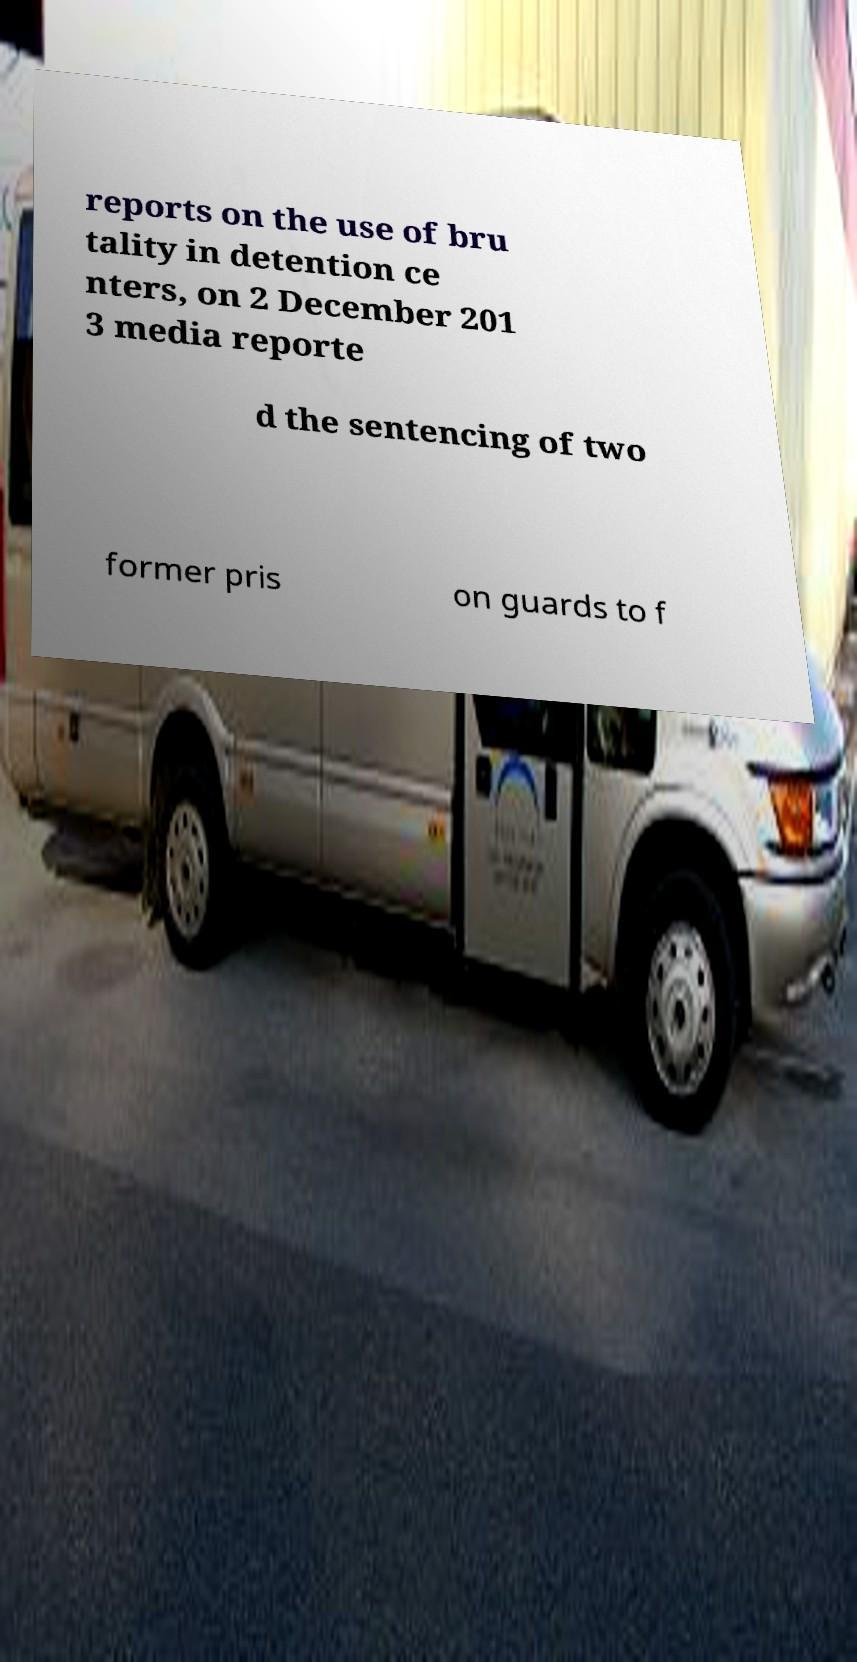Can you read and provide the text displayed in the image?This photo seems to have some interesting text. Can you extract and type it out for me? reports on the use of bru tality in detention ce nters, on 2 December 201 3 media reporte d the sentencing of two former pris on guards to f 